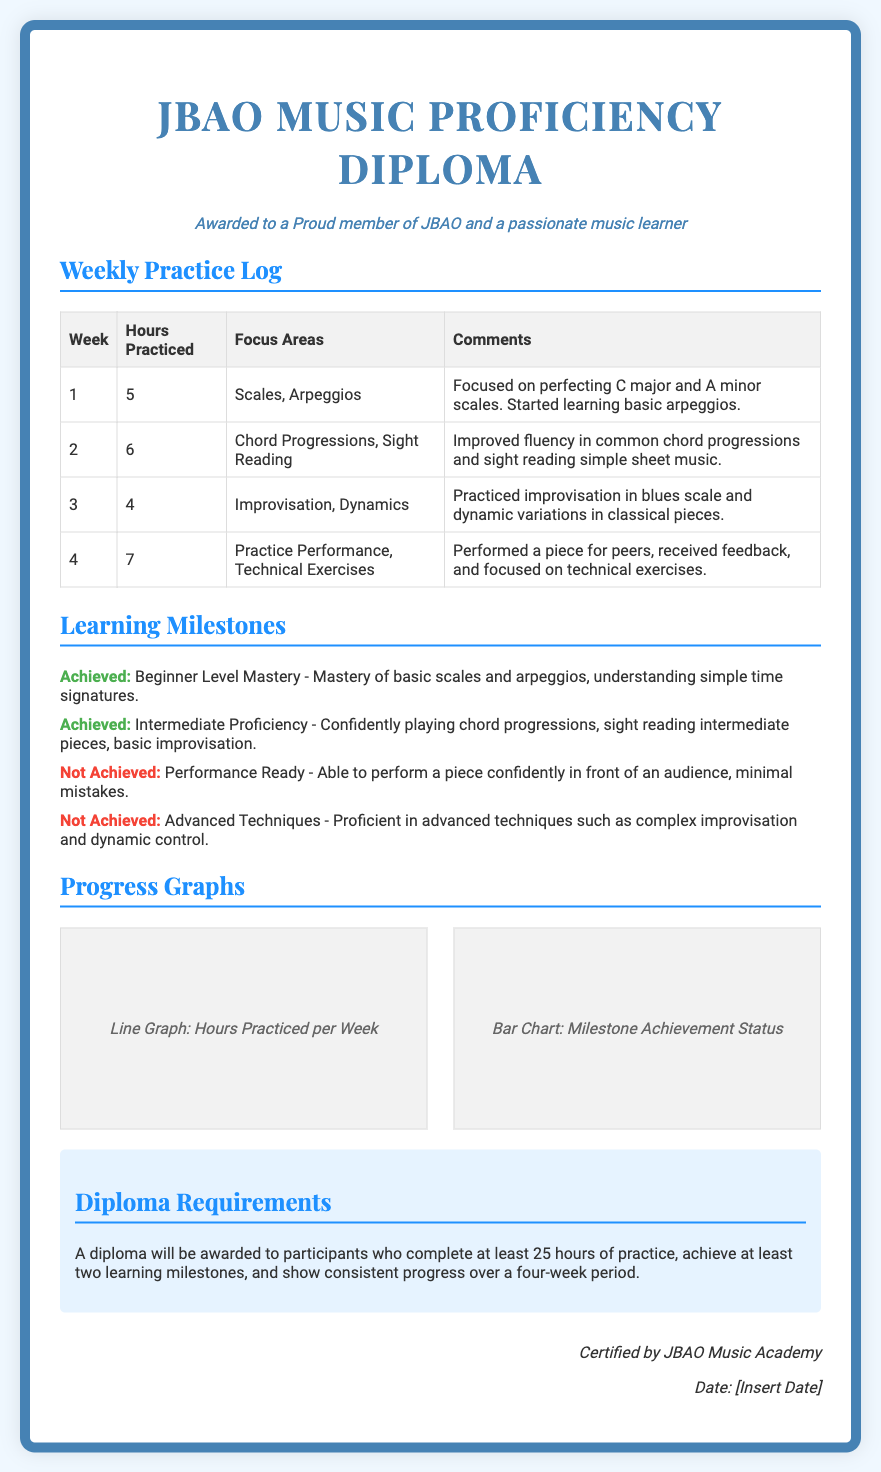what is the title of the document? The title of the document is displayed prominently at the top, indicating the purpose of the certificate.
Answer: JBAO Music Proficiency Diploma who is the certificate awarded to? The certificate specifies to whom it is awarded with a phrase indicating membership and passion for music.
Answer: a Proud member of JBAO and a passionate music learner how many hours were practiced in Week 2? The number of hours practiced during Week 2 is clearly listed in the practice log table.
Answer: 6 which milestone is not achieved? The document indicates which learning milestones have not been achieved, specifically noting the status.
Answer: Performance Ready what focus areas were practiced in Week 1? The focus areas practiced in Week 1 are detailed in the practice log table.
Answer: Scales, Arpeggios how many total hours were practiced over four weeks? The total hours can be calculated by summing the hours from the practice log for each week.
Answer: 22 name one technical area focused on in Week 4? The practice log mentions specific focus areas for each week, including Week 4.
Answer: Technical Exercises how many learning milestones are listed in total? The document outlines the learning milestones achieved and not achieved, allowing for a count.
Answer: 4 